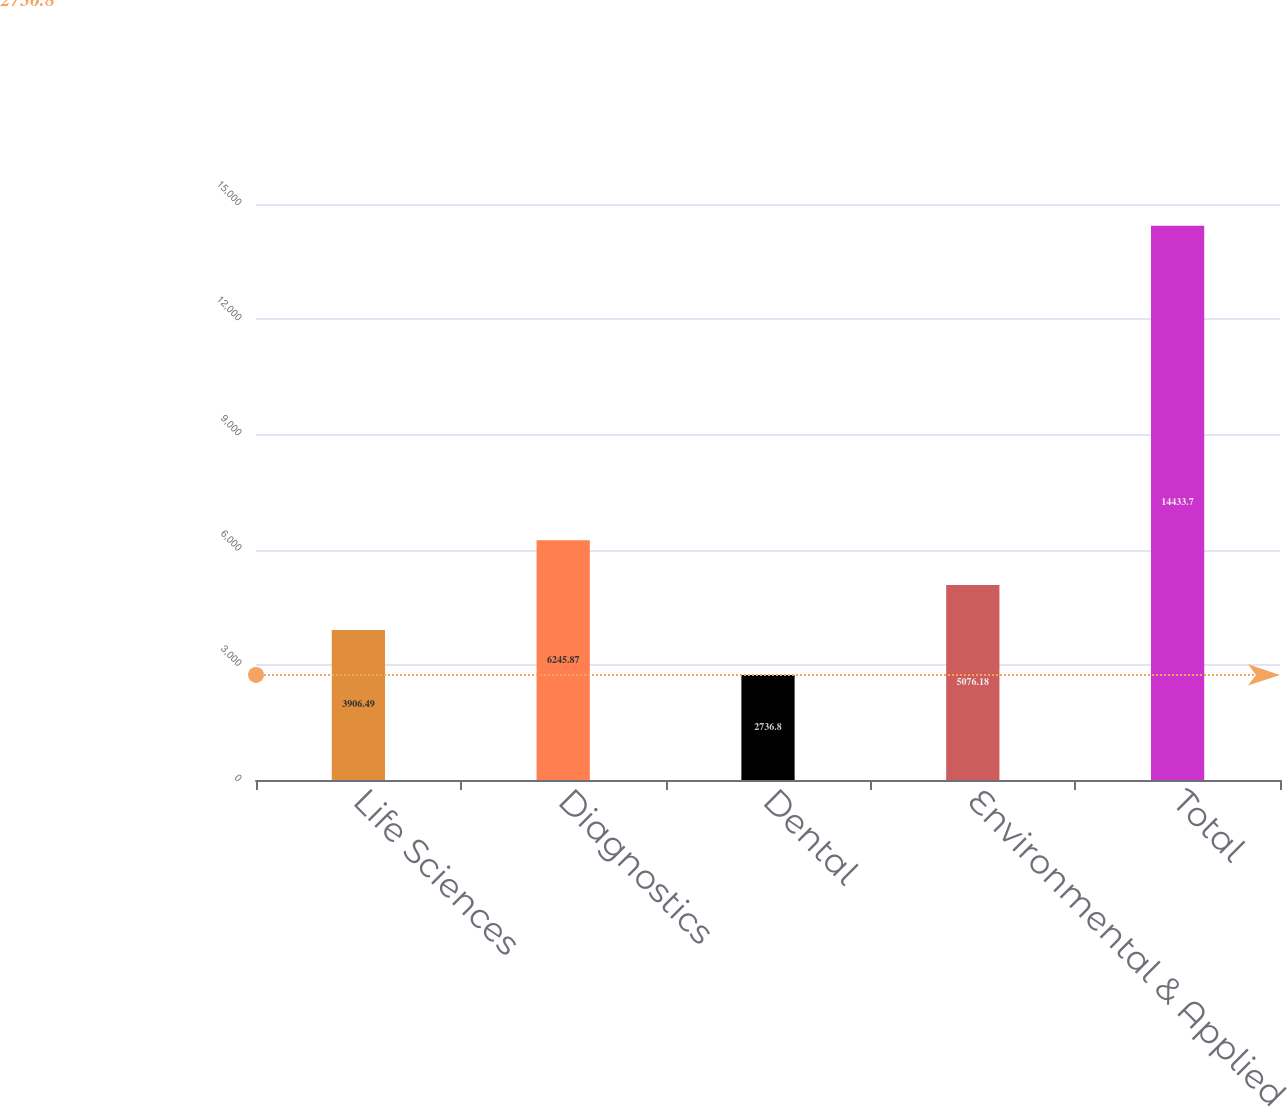Convert chart to OTSL. <chart><loc_0><loc_0><loc_500><loc_500><bar_chart><fcel>Life Sciences<fcel>Diagnostics<fcel>Dental<fcel>Environmental & Applied<fcel>Total<nl><fcel>3906.49<fcel>6245.87<fcel>2736.8<fcel>5076.18<fcel>14433.7<nl></chart> 